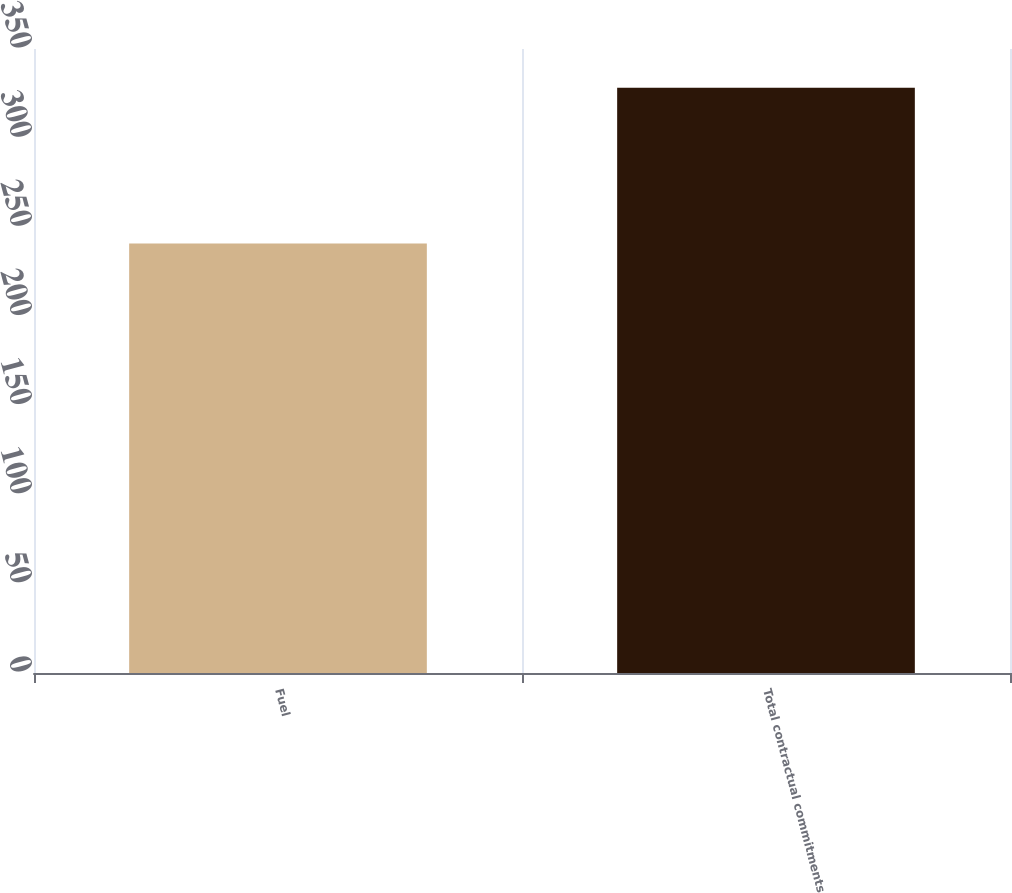<chart> <loc_0><loc_0><loc_500><loc_500><bar_chart><fcel>Fuel<fcel>Total contractual commitments<nl><fcel>240.9<fcel>328.3<nl></chart> 